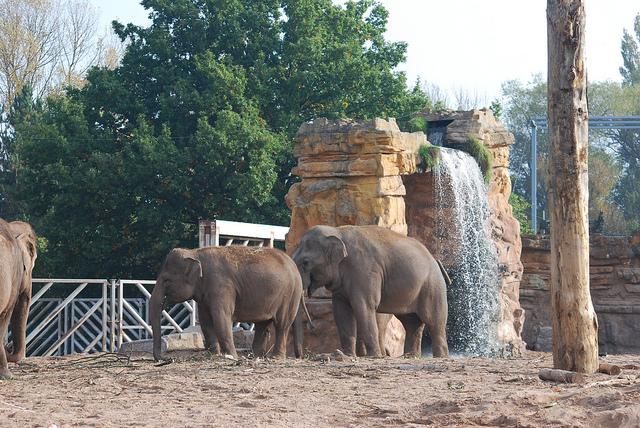What is near the elephants? waterfall 